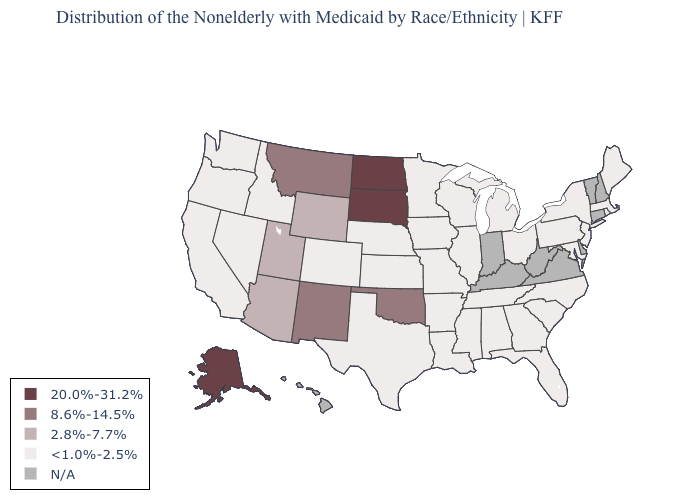Name the states that have a value in the range 20.0%-31.2%?
Short answer required. Alaska, North Dakota, South Dakota. What is the value of Colorado?
Keep it brief. <1.0%-2.5%. Name the states that have a value in the range <1.0%-2.5%?
Give a very brief answer. Alabama, Arkansas, California, Colorado, Florida, Georgia, Idaho, Illinois, Iowa, Kansas, Louisiana, Maine, Maryland, Massachusetts, Michigan, Minnesota, Mississippi, Missouri, Nebraska, Nevada, New Jersey, New York, North Carolina, Ohio, Oregon, Pennsylvania, Rhode Island, South Carolina, Tennessee, Texas, Washington, Wisconsin. What is the lowest value in the MidWest?
Be succinct. <1.0%-2.5%. Which states have the highest value in the USA?
Quick response, please. Alaska, North Dakota, South Dakota. What is the lowest value in the Northeast?
Concise answer only. <1.0%-2.5%. What is the lowest value in states that border Louisiana?
Answer briefly. <1.0%-2.5%. What is the highest value in the USA?
Give a very brief answer. 20.0%-31.2%. Name the states that have a value in the range N/A?
Give a very brief answer. Connecticut, Delaware, Hawaii, Indiana, Kentucky, New Hampshire, Vermont, Virginia, West Virginia. Among the states that border Missouri , does Oklahoma have the lowest value?
Short answer required. No. Which states have the lowest value in the USA?
Short answer required. Alabama, Arkansas, California, Colorado, Florida, Georgia, Idaho, Illinois, Iowa, Kansas, Louisiana, Maine, Maryland, Massachusetts, Michigan, Minnesota, Mississippi, Missouri, Nebraska, Nevada, New Jersey, New York, North Carolina, Ohio, Oregon, Pennsylvania, Rhode Island, South Carolina, Tennessee, Texas, Washington, Wisconsin. Among the states that border Missouri , which have the highest value?
Concise answer only. Oklahoma. Does North Dakota have the highest value in the MidWest?
Answer briefly. Yes. Does South Dakota have the highest value in the USA?
Give a very brief answer. Yes. Which states have the highest value in the USA?
Keep it brief. Alaska, North Dakota, South Dakota. 